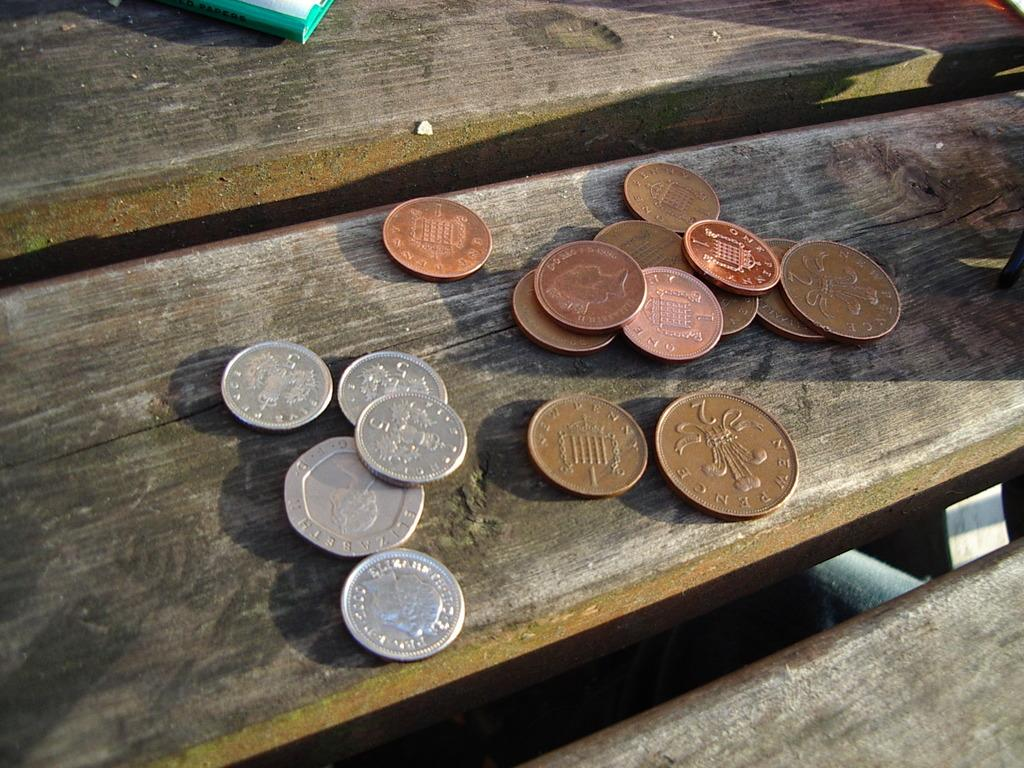Provide a one-sentence caption for the provided image. A couple of one cent pennies sit on a table. 